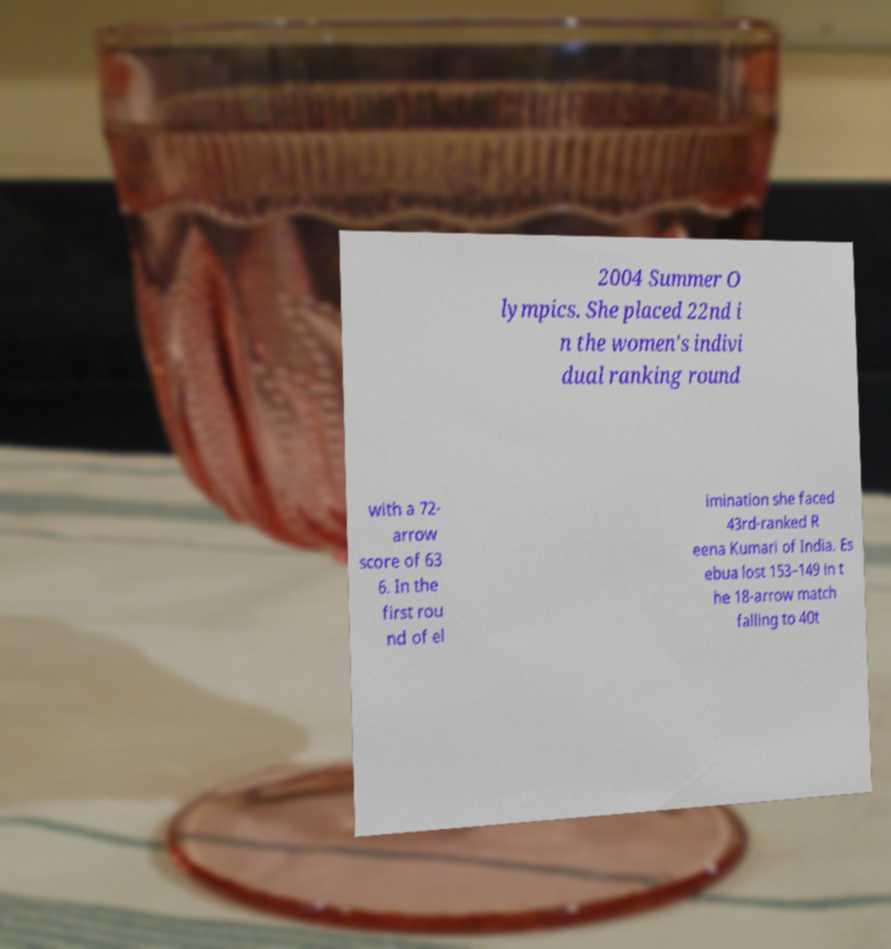Can you read and provide the text displayed in the image?This photo seems to have some interesting text. Can you extract and type it out for me? 2004 Summer O lympics. She placed 22nd i n the women's indivi dual ranking round with a 72- arrow score of 63 6. In the first rou nd of el imination she faced 43rd-ranked R eena Kumari of India. Es ebua lost 153–149 in t he 18-arrow match falling to 40t 